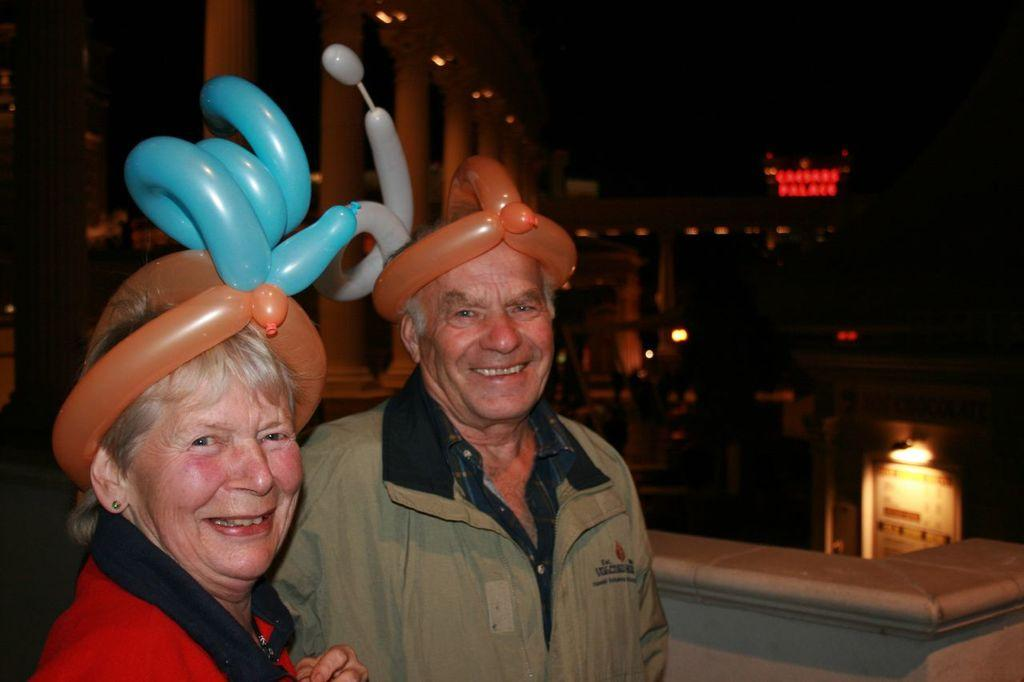How many persons are in the image? There are two persons in the image. What is the facial expression of the persons? The persons are smiling. What type of structures can be seen in the image? There are buildings in the image. What type of illumination is present in the image? There are lights in the image. What architectural elements can be observed in the image? There are pillars in the image. How would you describe the overall lighting condition in the image? The background of the image is dark. What arithmetic problem is being solved by the persons in the image? There is no indication in the image that the persons are solving an arithmetic problem. What type of nerves can be seen in the image? There are no visible nerves in the image; it features two persons, buildings, lights, and pillars. 